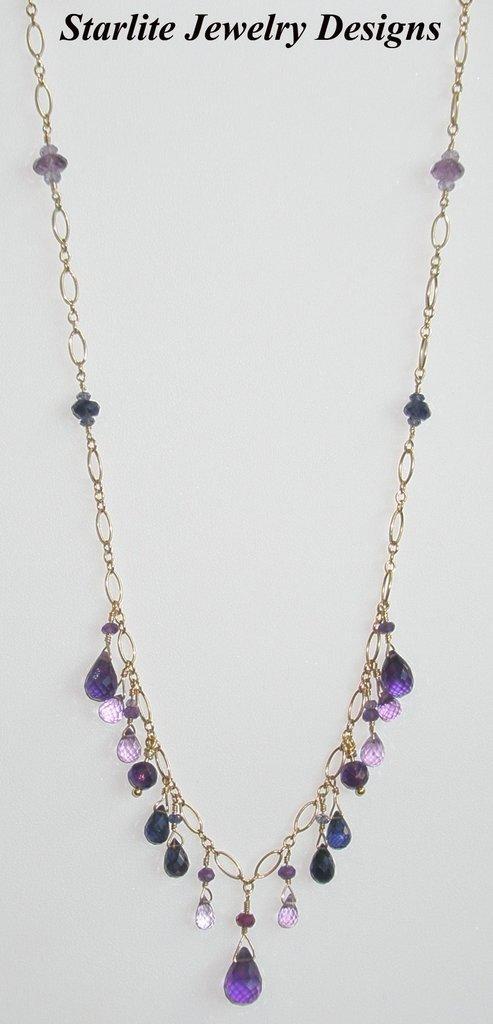Please provide a concise description of this image. In this picture there is a necklace with violet color stones. At the top there is some text. 